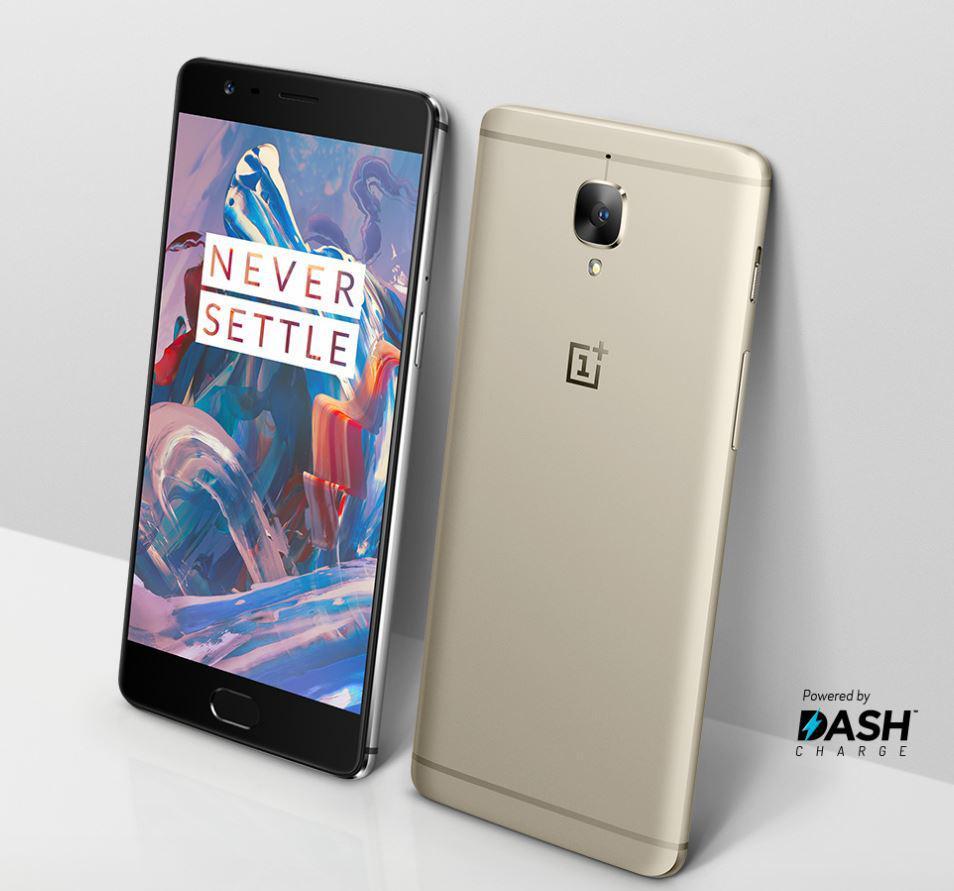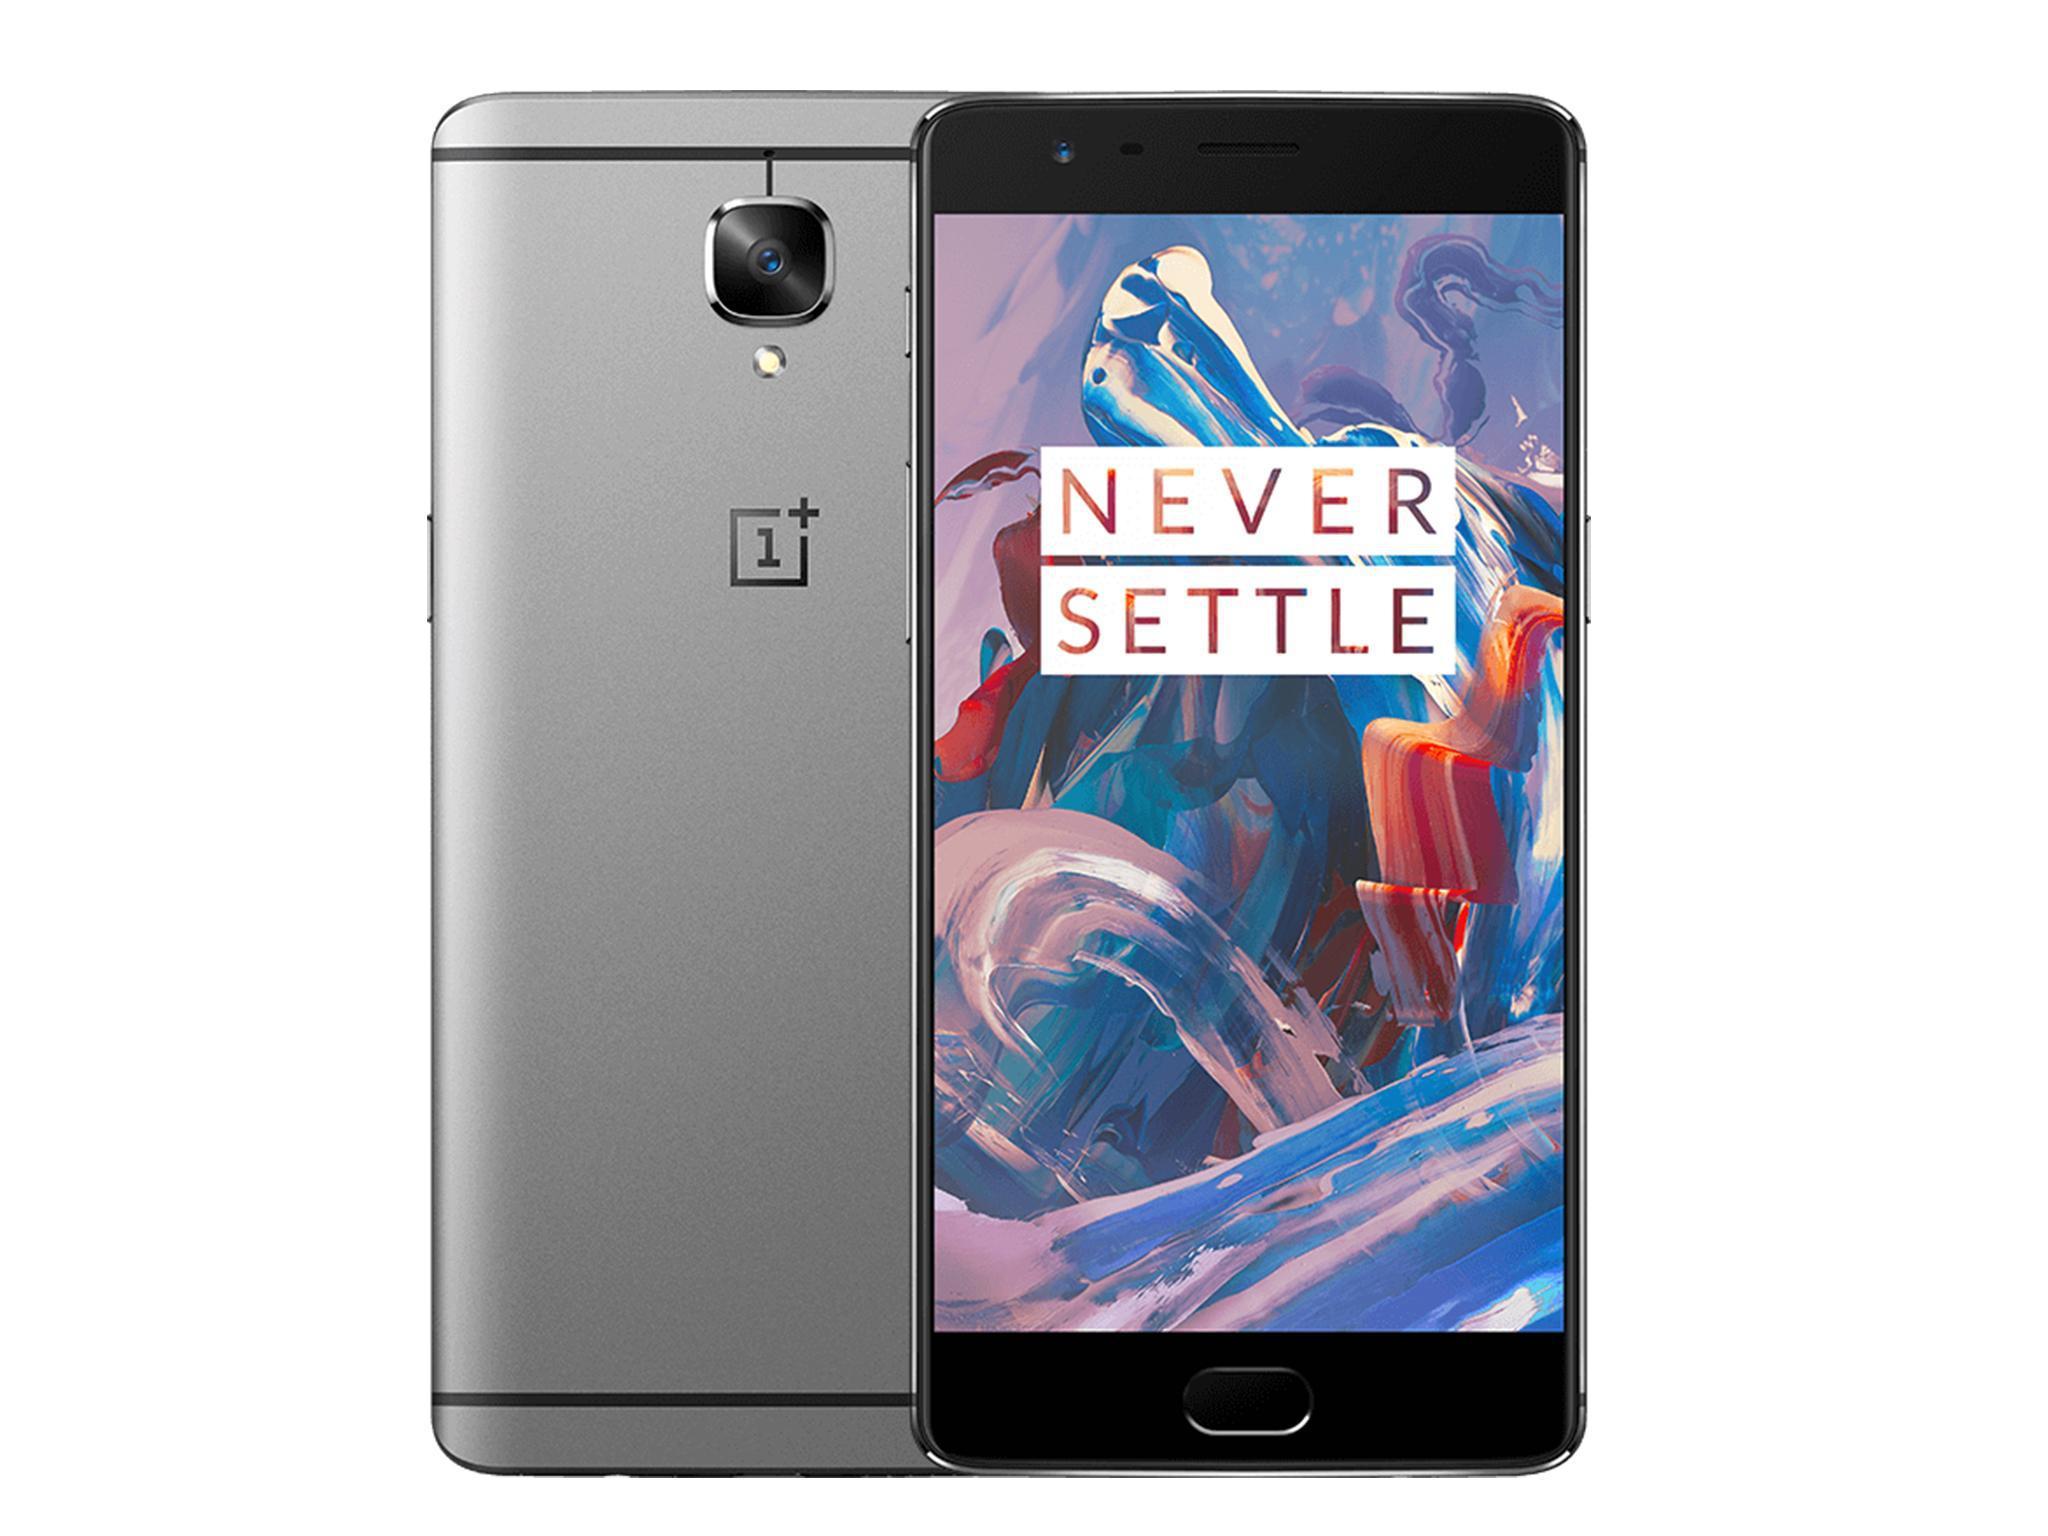The first image is the image on the left, the second image is the image on the right. Considering the images on both sides, is "The left and right image contains the same number of phones with the front side parallel with the back of the other phone." valid? Answer yes or no. Yes. 